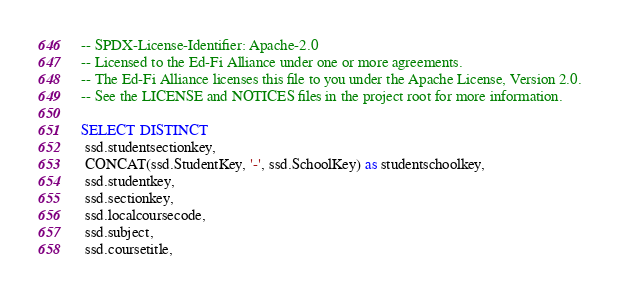<code> <loc_0><loc_0><loc_500><loc_500><_SQL_>-- SPDX-License-Identifier: Apache-2.0
-- Licensed to the Ed-Fi Alliance under one or more agreements.
-- The Ed-Fi Alliance licenses this file to you under the Apache License, Version 2.0.
-- See the LICENSE and NOTICES files in the project root for more information.

SELECT DISTINCT
 ssd.studentsectionkey,
 CONCAT(ssd.StudentKey, '-', ssd.SchoolKey) as studentschoolkey,
 ssd.studentkey,
 ssd.sectionkey,
 ssd.localcoursecode,
 ssd.subject,
 ssd.coursetitle,</code> 